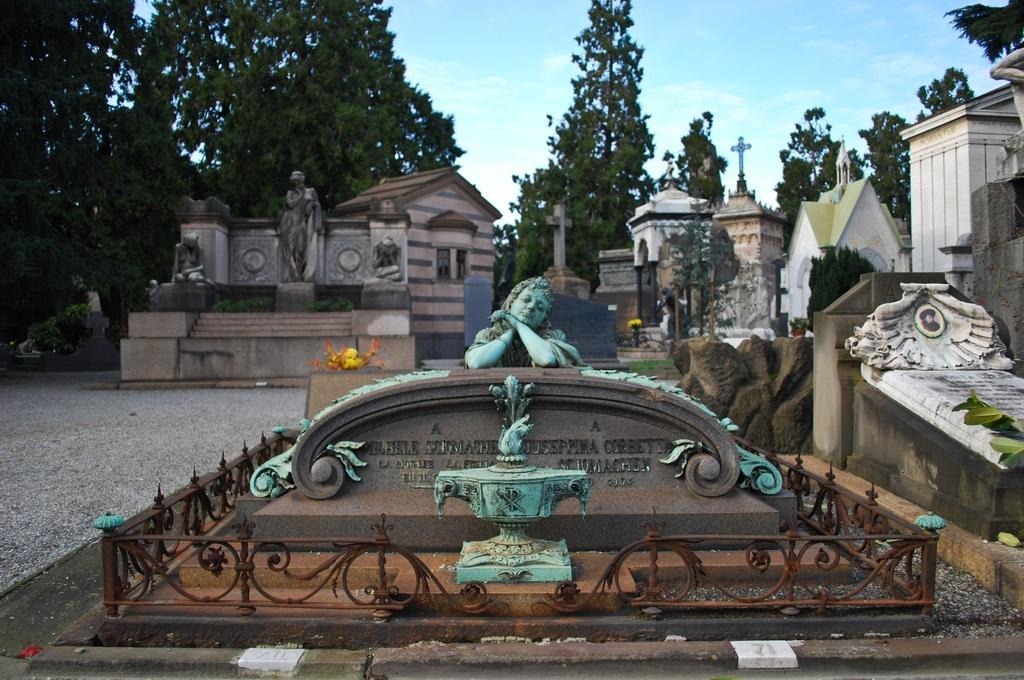Could you give a brief overview of what you see in this image? In this image we can see sculptures, fencing, houses, trees and in the background we can also see the sky. 